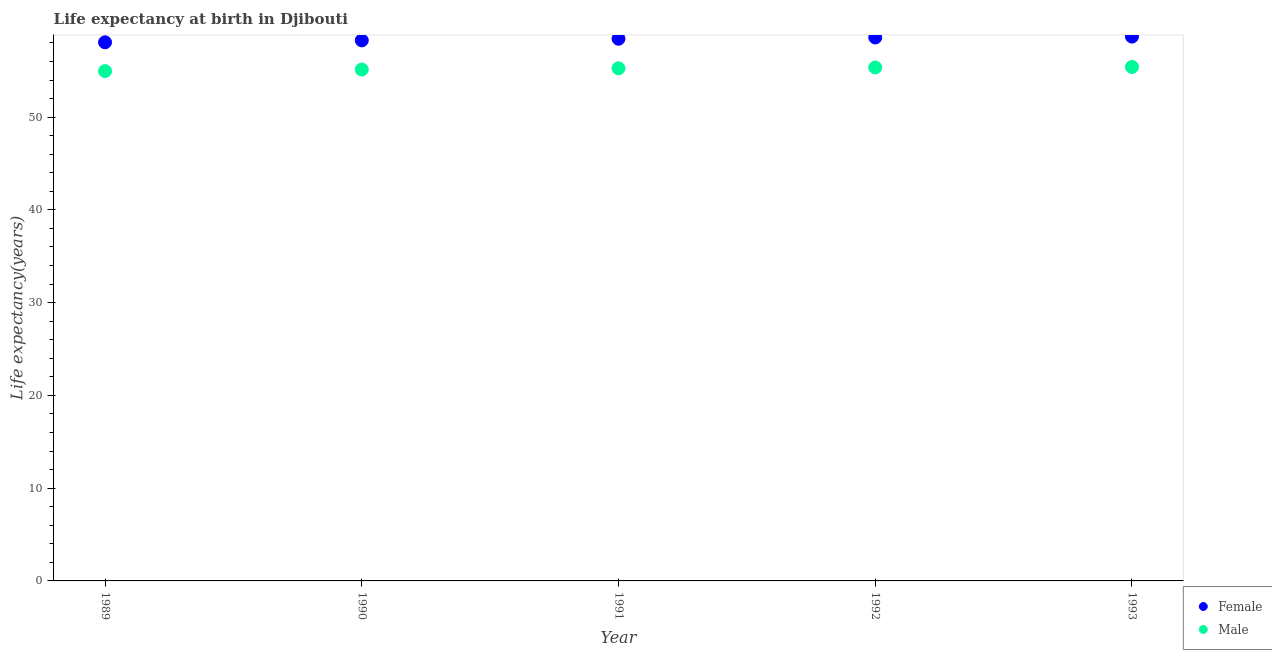Is the number of dotlines equal to the number of legend labels?
Provide a succinct answer. Yes. What is the life expectancy(female) in 1989?
Your answer should be compact. 58.06. Across all years, what is the maximum life expectancy(female)?
Provide a short and direct response. 58.68. Across all years, what is the minimum life expectancy(female)?
Offer a very short reply. 58.06. What is the total life expectancy(male) in the graph?
Your response must be concise. 276.11. What is the difference between the life expectancy(male) in 1990 and that in 1992?
Give a very brief answer. -0.22. What is the difference between the life expectancy(female) in 1991 and the life expectancy(male) in 1992?
Provide a short and direct response. 3.09. What is the average life expectancy(male) per year?
Offer a terse response. 55.22. In the year 1993, what is the difference between the life expectancy(female) and life expectancy(male)?
Provide a short and direct response. 3.27. In how many years, is the life expectancy(female) greater than 12 years?
Provide a short and direct response. 5. What is the ratio of the life expectancy(male) in 1990 to that in 1991?
Your answer should be compact. 1. Is the life expectancy(male) in 1991 less than that in 1992?
Offer a terse response. Yes. What is the difference between the highest and the second highest life expectancy(male)?
Your response must be concise. 0.05. What is the difference between the highest and the lowest life expectancy(female)?
Provide a succinct answer. 0.62. Is the life expectancy(male) strictly less than the life expectancy(female) over the years?
Offer a terse response. Yes. How many dotlines are there?
Offer a terse response. 2. How many years are there in the graph?
Your response must be concise. 5. Are the values on the major ticks of Y-axis written in scientific E-notation?
Provide a succinct answer. No. Does the graph contain any zero values?
Offer a terse response. No. Does the graph contain grids?
Keep it short and to the point. No. Where does the legend appear in the graph?
Provide a short and direct response. Bottom right. How many legend labels are there?
Your answer should be compact. 2. What is the title of the graph?
Provide a short and direct response. Life expectancy at birth in Djibouti. What is the label or title of the X-axis?
Make the answer very short. Year. What is the label or title of the Y-axis?
Ensure brevity in your answer.  Life expectancy(years). What is the Life expectancy(years) in Female in 1989?
Offer a terse response. 58.06. What is the Life expectancy(years) in Male in 1989?
Provide a short and direct response. 54.96. What is the Life expectancy(years) of Female in 1990?
Offer a very short reply. 58.27. What is the Life expectancy(years) in Male in 1990?
Provide a succinct answer. 55.13. What is the Life expectancy(years) of Female in 1991?
Offer a terse response. 58.45. What is the Life expectancy(years) in Male in 1991?
Your answer should be compact. 55.26. What is the Life expectancy(years) in Female in 1992?
Keep it short and to the point. 58.59. What is the Life expectancy(years) in Male in 1992?
Your answer should be compact. 55.35. What is the Life expectancy(years) of Female in 1993?
Offer a terse response. 58.68. What is the Life expectancy(years) of Male in 1993?
Offer a terse response. 55.41. Across all years, what is the maximum Life expectancy(years) in Female?
Your answer should be very brief. 58.68. Across all years, what is the maximum Life expectancy(years) of Male?
Make the answer very short. 55.41. Across all years, what is the minimum Life expectancy(years) of Female?
Make the answer very short. 58.06. Across all years, what is the minimum Life expectancy(years) in Male?
Provide a succinct answer. 54.96. What is the total Life expectancy(years) in Female in the graph?
Your response must be concise. 292.05. What is the total Life expectancy(years) in Male in the graph?
Offer a terse response. 276.11. What is the difference between the Life expectancy(years) in Female in 1989 and that in 1990?
Provide a short and direct response. -0.21. What is the difference between the Life expectancy(years) of Male in 1989 and that in 1990?
Provide a short and direct response. -0.17. What is the difference between the Life expectancy(years) of Female in 1989 and that in 1991?
Provide a succinct answer. -0.38. What is the difference between the Life expectancy(years) of Male in 1989 and that in 1991?
Ensure brevity in your answer.  -0.3. What is the difference between the Life expectancy(years) in Female in 1989 and that in 1992?
Offer a very short reply. -0.52. What is the difference between the Life expectancy(years) of Male in 1989 and that in 1992?
Give a very brief answer. -0.4. What is the difference between the Life expectancy(years) in Female in 1989 and that in 1993?
Keep it short and to the point. -0.61. What is the difference between the Life expectancy(years) in Male in 1989 and that in 1993?
Make the answer very short. -0.45. What is the difference between the Life expectancy(years) of Female in 1990 and that in 1991?
Your answer should be compact. -0.17. What is the difference between the Life expectancy(years) of Male in 1990 and that in 1991?
Keep it short and to the point. -0.13. What is the difference between the Life expectancy(years) of Female in 1990 and that in 1992?
Make the answer very short. -0.31. What is the difference between the Life expectancy(years) in Male in 1990 and that in 1992?
Offer a terse response. -0.22. What is the difference between the Life expectancy(years) in Female in 1990 and that in 1993?
Offer a very short reply. -0.41. What is the difference between the Life expectancy(years) of Male in 1990 and that in 1993?
Offer a very short reply. -0.28. What is the difference between the Life expectancy(years) in Female in 1991 and that in 1992?
Offer a terse response. -0.14. What is the difference between the Life expectancy(years) in Male in 1991 and that in 1992?
Offer a terse response. -0.09. What is the difference between the Life expectancy(years) in Female in 1991 and that in 1993?
Keep it short and to the point. -0.23. What is the difference between the Life expectancy(years) in Male in 1991 and that in 1993?
Offer a very short reply. -0.14. What is the difference between the Life expectancy(years) of Female in 1992 and that in 1993?
Offer a very short reply. -0.1. What is the difference between the Life expectancy(years) in Male in 1992 and that in 1993?
Offer a very short reply. -0.05. What is the difference between the Life expectancy(years) in Female in 1989 and the Life expectancy(years) in Male in 1990?
Offer a terse response. 2.94. What is the difference between the Life expectancy(years) in Female in 1989 and the Life expectancy(years) in Male in 1991?
Ensure brevity in your answer.  2.8. What is the difference between the Life expectancy(years) of Female in 1989 and the Life expectancy(years) of Male in 1992?
Ensure brevity in your answer.  2.71. What is the difference between the Life expectancy(years) in Female in 1989 and the Life expectancy(years) in Male in 1993?
Your answer should be very brief. 2.66. What is the difference between the Life expectancy(years) in Female in 1990 and the Life expectancy(years) in Male in 1991?
Offer a very short reply. 3.01. What is the difference between the Life expectancy(years) in Female in 1990 and the Life expectancy(years) in Male in 1992?
Keep it short and to the point. 2.92. What is the difference between the Life expectancy(years) of Female in 1990 and the Life expectancy(years) of Male in 1993?
Give a very brief answer. 2.87. What is the difference between the Life expectancy(years) in Female in 1991 and the Life expectancy(years) in Male in 1992?
Keep it short and to the point. 3.1. What is the difference between the Life expectancy(years) in Female in 1991 and the Life expectancy(years) in Male in 1993?
Your response must be concise. 3.04. What is the difference between the Life expectancy(years) in Female in 1992 and the Life expectancy(years) in Male in 1993?
Your answer should be very brief. 3.18. What is the average Life expectancy(years) in Female per year?
Ensure brevity in your answer.  58.41. What is the average Life expectancy(years) of Male per year?
Provide a short and direct response. 55.22. In the year 1989, what is the difference between the Life expectancy(years) of Female and Life expectancy(years) of Male?
Provide a succinct answer. 3.11. In the year 1990, what is the difference between the Life expectancy(years) of Female and Life expectancy(years) of Male?
Keep it short and to the point. 3.14. In the year 1991, what is the difference between the Life expectancy(years) of Female and Life expectancy(years) of Male?
Ensure brevity in your answer.  3.19. In the year 1992, what is the difference between the Life expectancy(years) of Female and Life expectancy(years) of Male?
Offer a very short reply. 3.23. In the year 1993, what is the difference between the Life expectancy(years) of Female and Life expectancy(years) of Male?
Keep it short and to the point. 3.27. What is the ratio of the Life expectancy(years) of Male in 1989 to that in 1990?
Keep it short and to the point. 1. What is the ratio of the Life expectancy(years) in Female in 1989 to that in 1991?
Your answer should be very brief. 0.99. What is the ratio of the Life expectancy(years) of Female in 1989 to that in 1992?
Provide a short and direct response. 0.99. What is the ratio of the Life expectancy(years) of Male in 1989 to that in 1992?
Give a very brief answer. 0.99. What is the ratio of the Life expectancy(years) in Male in 1989 to that in 1993?
Give a very brief answer. 0.99. What is the ratio of the Life expectancy(years) in Male in 1990 to that in 1991?
Offer a very short reply. 1. What is the ratio of the Life expectancy(years) in Male in 1990 to that in 1992?
Keep it short and to the point. 1. What is the ratio of the Life expectancy(years) of Female in 1990 to that in 1993?
Offer a very short reply. 0.99. What is the ratio of the Life expectancy(years) in Female in 1991 to that in 1992?
Provide a succinct answer. 1. What is the ratio of the Life expectancy(years) of Female in 1991 to that in 1993?
Your response must be concise. 1. What is the ratio of the Life expectancy(years) of Male in 1991 to that in 1993?
Make the answer very short. 1. What is the ratio of the Life expectancy(years) in Female in 1992 to that in 1993?
Make the answer very short. 1. What is the ratio of the Life expectancy(years) in Male in 1992 to that in 1993?
Offer a very short reply. 1. What is the difference between the highest and the second highest Life expectancy(years) in Female?
Your answer should be very brief. 0.1. What is the difference between the highest and the second highest Life expectancy(years) in Male?
Make the answer very short. 0.05. What is the difference between the highest and the lowest Life expectancy(years) of Female?
Keep it short and to the point. 0.61. What is the difference between the highest and the lowest Life expectancy(years) of Male?
Provide a short and direct response. 0.45. 